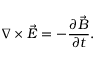Convert formula to latex. <formula><loc_0><loc_0><loc_500><loc_500>\nabla \times { \vec { E } } = - \frac { \partial \vec { B } } { \partial t } .</formula> 